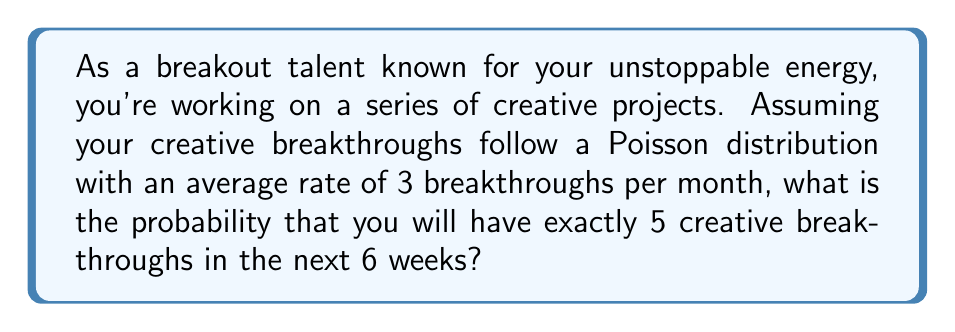Show me your answer to this math problem. To solve this problem, we'll use the Poisson distribution formula:

$$P(X = k) = \frac{e^{-\lambda} \cdot \lambda^k}{k!}$$

Where:
$\lambda$ = average number of events in the given time period
$k$ = number of events we're calculating the probability for
$e$ = Euler's number (approximately 2.71828)

Step 1: Calculate $\lambda$ for 6 weeks
- Rate is 3 breakthroughs per month
- 6 weeks = 1.5 months
- $\lambda = 3 \cdot 1.5 = 4.5$

Step 2: Apply the Poisson formula with $k = 5$ and $\lambda = 4.5$

$$P(X = 5) = \frac{e^{-4.5} \cdot 4.5^5}{5!}$$

Step 3: Calculate each part
- $e^{-4.5} \approx 0.0111$
- $4.5^5 \approx 1845.2813$
- $5! = 120$

Step 4: Put it all together
$$P(X = 5) = \frac{0.0111 \cdot 1845.2813}{120} \approx 0.1708$$

Step 5: Convert to percentage
$0.1708 \cdot 100\% = 17.08\%$
Answer: 17.08% 